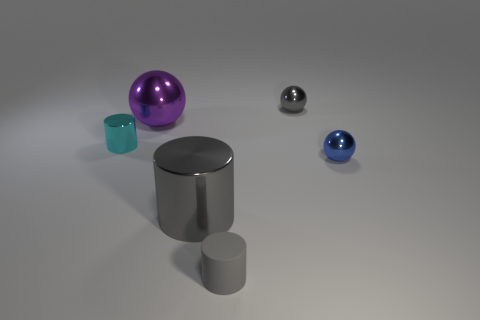There is a metallic ball in front of the small thing left of the gray matte thing; how big is it?
Keep it short and to the point. Small. What is the shape of the blue metal object that is the same size as the cyan metal cylinder?
Keep it short and to the point. Sphere. The large shiny thing that is in front of the tiny metallic sphere that is to the right of the small sphere behind the tiny cyan thing is what shape?
Your answer should be very brief. Cylinder. Do the small thing that is left of the big sphere and the metal object that is behind the purple shiny sphere have the same color?
Provide a succinct answer. No. What number of gray shiny things are there?
Offer a terse response. 2. Are there any metal cylinders in front of the blue ball?
Your answer should be compact. Yes. Does the small cylinder in front of the large cylinder have the same material as the tiny cylinder left of the big purple metallic object?
Your response must be concise. No. Is the number of tiny metal things behind the tiny gray sphere less than the number of gray spheres?
Give a very brief answer. Yes. There is a large object on the left side of the big gray cylinder; what color is it?
Provide a succinct answer. Purple. What material is the big thing in front of the small shiny sphere that is to the right of the gray ball?
Offer a very short reply. Metal. 